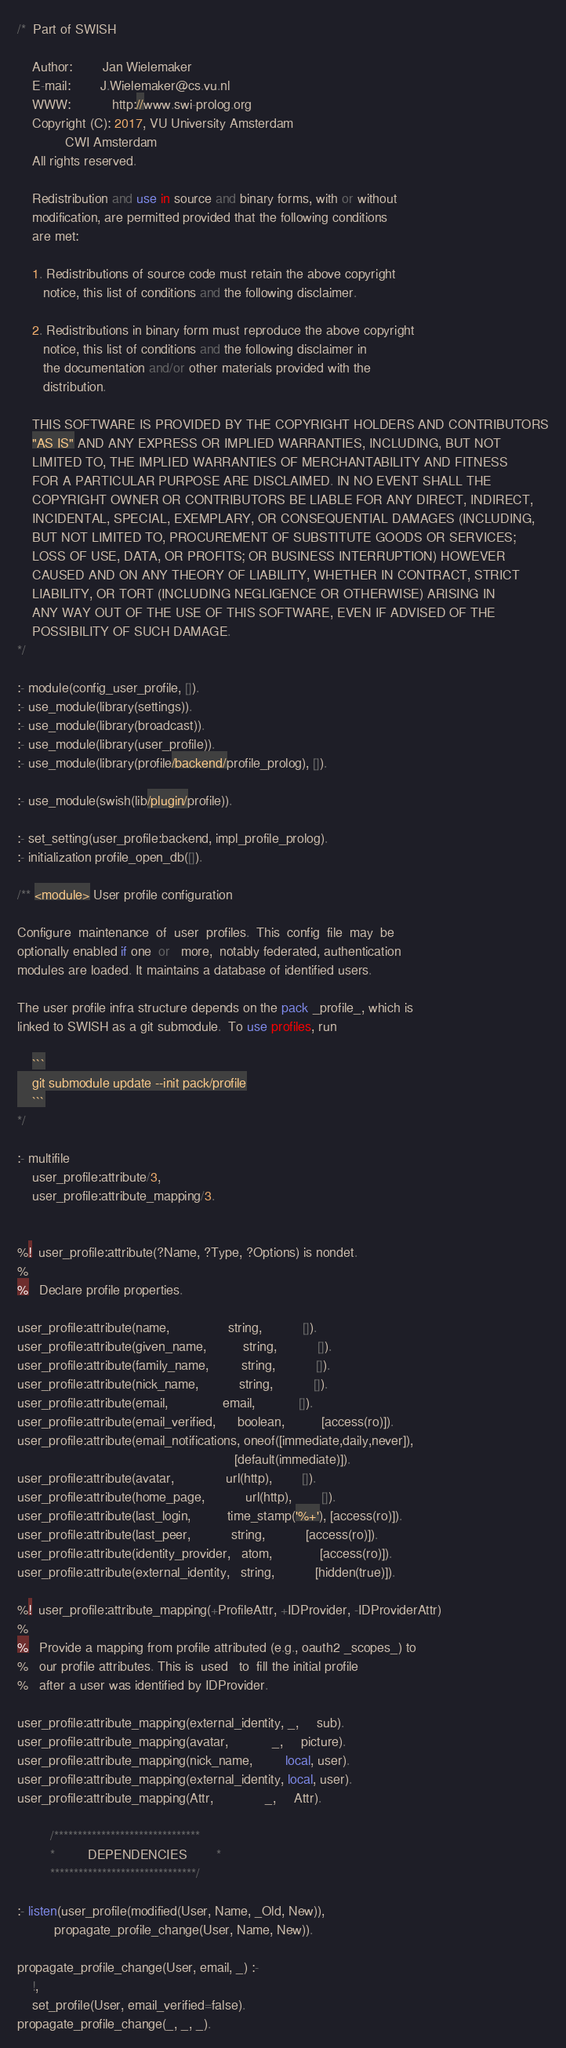Convert code to text. <code><loc_0><loc_0><loc_500><loc_500><_Perl_>/*  Part of SWISH

    Author:        Jan Wielemaker
    E-mail:        J.Wielemaker@cs.vu.nl
    WWW:           http://www.swi-prolog.org
    Copyright (C): 2017, VU University Amsterdam
			 CWI Amsterdam
    All rights reserved.

    Redistribution and use in source and binary forms, with or without
    modification, are permitted provided that the following conditions
    are met:

    1. Redistributions of source code must retain the above copyright
       notice, this list of conditions and the following disclaimer.

    2. Redistributions in binary form must reproduce the above copyright
       notice, this list of conditions and the following disclaimer in
       the documentation and/or other materials provided with the
       distribution.

    THIS SOFTWARE IS PROVIDED BY THE COPYRIGHT HOLDERS AND CONTRIBUTORS
    "AS IS" AND ANY EXPRESS OR IMPLIED WARRANTIES, INCLUDING, BUT NOT
    LIMITED TO, THE IMPLIED WARRANTIES OF MERCHANTABILITY AND FITNESS
    FOR A PARTICULAR PURPOSE ARE DISCLAIMED. IN NO EVENT SHALL THE
    COPYRIGHT OWNER OR CONTRIBUTORS BE LIABLE FOR ANY DIRECT, INDIRECT,
    INCIDENTAL, SPECIAL, EXEMPLARY, OR CONSEQUENTIAL DAMAGES (INCLUDING,
    BUT NOT LIMITED TO, PROCUREMENT OF SUBSTITUTE GOODS OR SERVICES;
    LOSS OF USE, DATA, OR PROFITS; OR BUSINESS INTERRUPTION) HOWEVER
    CAUSED AND ON ANY THEORY OF LIABILITY, WHETHER IN CONTRACT, STRICT
    LIABILITY, OR TORT (INCLUDING NEGLIGENCE OR OTHERWISE) ARISING IN
    ANY WAY OUT OF THE USE OF THIS SOFTWARE, EVEN IF ADVISED OF THE
    POSSIBILITY OF SUCH DAMAGE.
*/

:- module(config_user_profile, []).
:- use_module(library(settings)).
:- use_module(library(broadcast)).
:- use_module(library(user_profile)).
:- use_module(library(profile/backend/profile_prolog), []).

:- use_module(swish(lib/plugin/profile)).

:- set_setting(user_profile:backend, impl_profile_prolog).
:- initialization profile_open_db([]).

/** <module> User profile configuration

Configure  maintenance  of  user  profiles.  This  config  file  may  be
optionally enabled if one  or   more,  notably federated, authentication
modules are loaded. It maintains a database of identified users.

The user profile infra structure depends on the pack _profile_, which is
linked to SWISH as a git submodule.  To use profiles, run

    ```
    git submodule update --init pack/profile
    ```
*/

:- multifile
    user_profile:attribute/3,
    user_profile:attribute_mapping/3.


%!  user_profile:attribute(?Name, ?Type, ?Options) is nondet.
%
%   Declare profile properties.

user_profile:attribute(name,                string,           []).
user_profile:attribute(given_name,          string,           []).
user_profile:attribute(family_name,         string,           []).
user_profile:attribute(nick_name,           string,           []).
user_profile:attribute(email,               email,            []).
user_profile:attribute(email_verified,      boolean,          [access(ro)]).
user_profile:attribute(email_notifications, oneof([immediate,daily,never]),
                                                           [default(immediate)]).
user_profile:attribute(avatar,              url(http),        []).
user_profile:attribute(home_page,           url(http),        []).
user_profile:attribute(last_login,          time_stamp('%+'), [access(ro)]).
user_profile:attribute(last_peer,           string,           [access(ro)]).
user_profile:attribute(identity_provider,   atom,             [access(ro)]).
user_profile:attribute(external_identity,   string,           [hidden(true)]).

%!  user_profile:attribute_mapping(+ProfileAttr, +IDProvider, -IDProviderAttr)
%
%   Provide a mapping from profile attributed (e.g., oauth2 _scopes_) to
%   our profile attributes. This is  used   to  fill the initial profile
%   after a user was identified by IDProvider.

user_profile:attribute_mapping(external_identity, _,     sub).
user_profile:attribute_mapping(avatar,            _,     picture).
user_profile:attribute_mapping(nick_name,         local, user).
user_profile:attribute_mapping(external_identity, local, user).
user_profile:attribute_mapping(Attr,              _,     Attr).

		 /*******************************
		 *         DEPENDENCIES		*
		 *******************************/

:- listen(user_profile(modified(User, Name, _Old, New)),
          propagate_profile_change(User, Name, New)).

propagate_profile_change(User, email, _) :-
    !,
    set_profile(User, email_verified=false).
propagate_profile_change(_, _, _).
</code> 